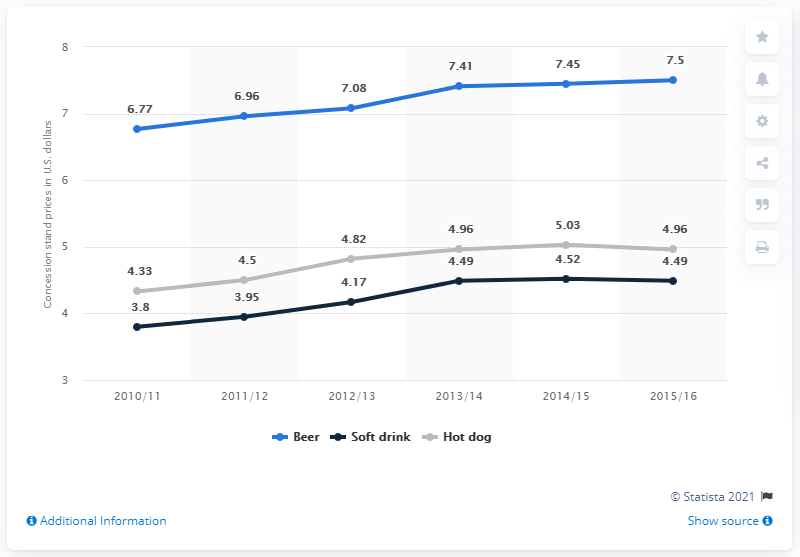Give some essential details in this illustration. According to data collected during the 2010/11 season, the average price of a hot dog was 4.33 dollars. The highest value in the blue line chart is approximately 7.5. The highest value in the black line chart is 4.52. 